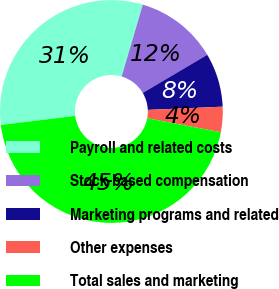<chart> <loc_0><loc_0><loc_500><loc_500><pie_chart><fcel>Payroll and related costs<fcel>Stock-based compensation<fcel>Marketing programs and related<fcel>Other expenses<fcel>Total sales and marketing<nl><fcel>31.49%<fcel>11.95%<fcel>7.81%<fcel>3.67%<fcel>45.08%<nl></chart> 